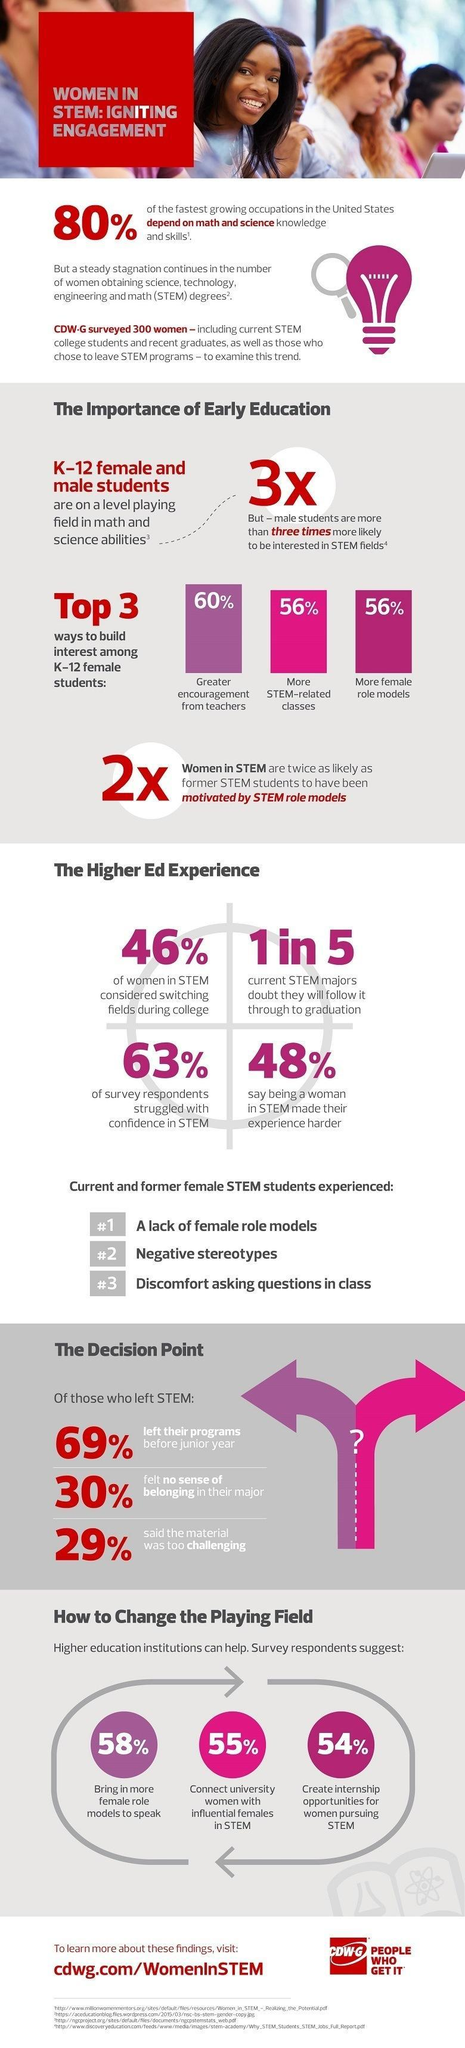What percentage of STEM graduates believed their subject was too much to handle?
Answer the question with a short phrase. 29% What percentage of STEM graduates quit the course in the initial year itself? 69% What percentage of STEM graduates were not sure about the curriculum? 63% What is the third problem faced by STEM graduates? Discomfort asking questions in class What is the second problem faced by STEM graduates? Negative Stereotypes 